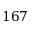<formula> <loc_0><loc_0><loc_500><loc_500>1 6 7</formula> 